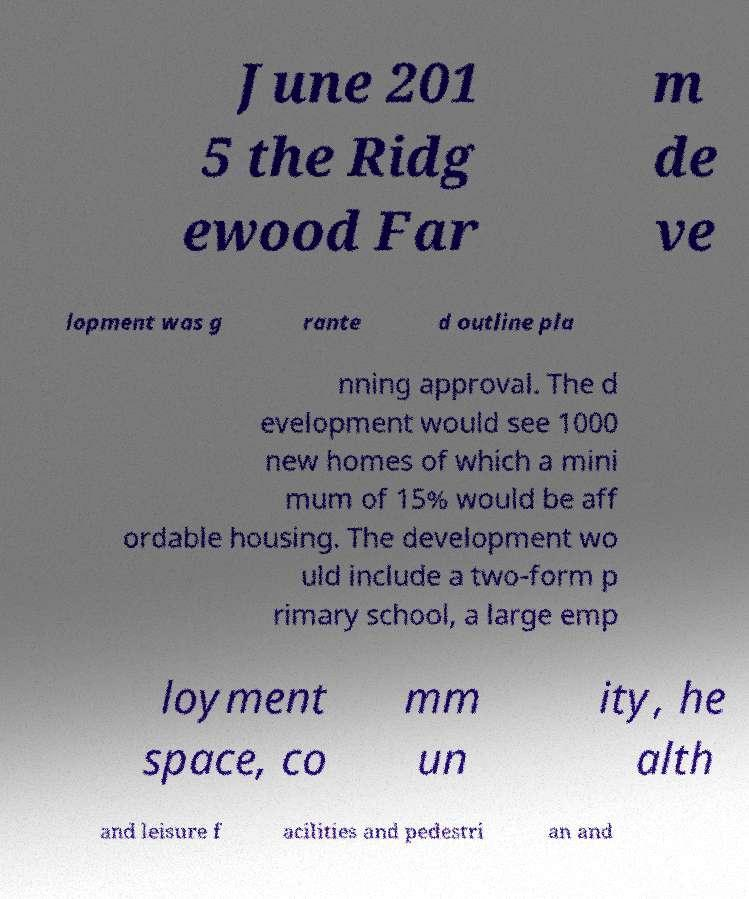Could you extract and type out the text from this image? June 201 5 the Ridg ewood Far m de ve lopment was g rante d outline pla nning approval. The d evelopment would see 1000 new homes of which a mini mum of 15% would be aff ordable housing. The development wo uld include a two-form p rimary school, a large emp loyment space, co mm un ity, he alth and leisure f acilities and pedestri an and 